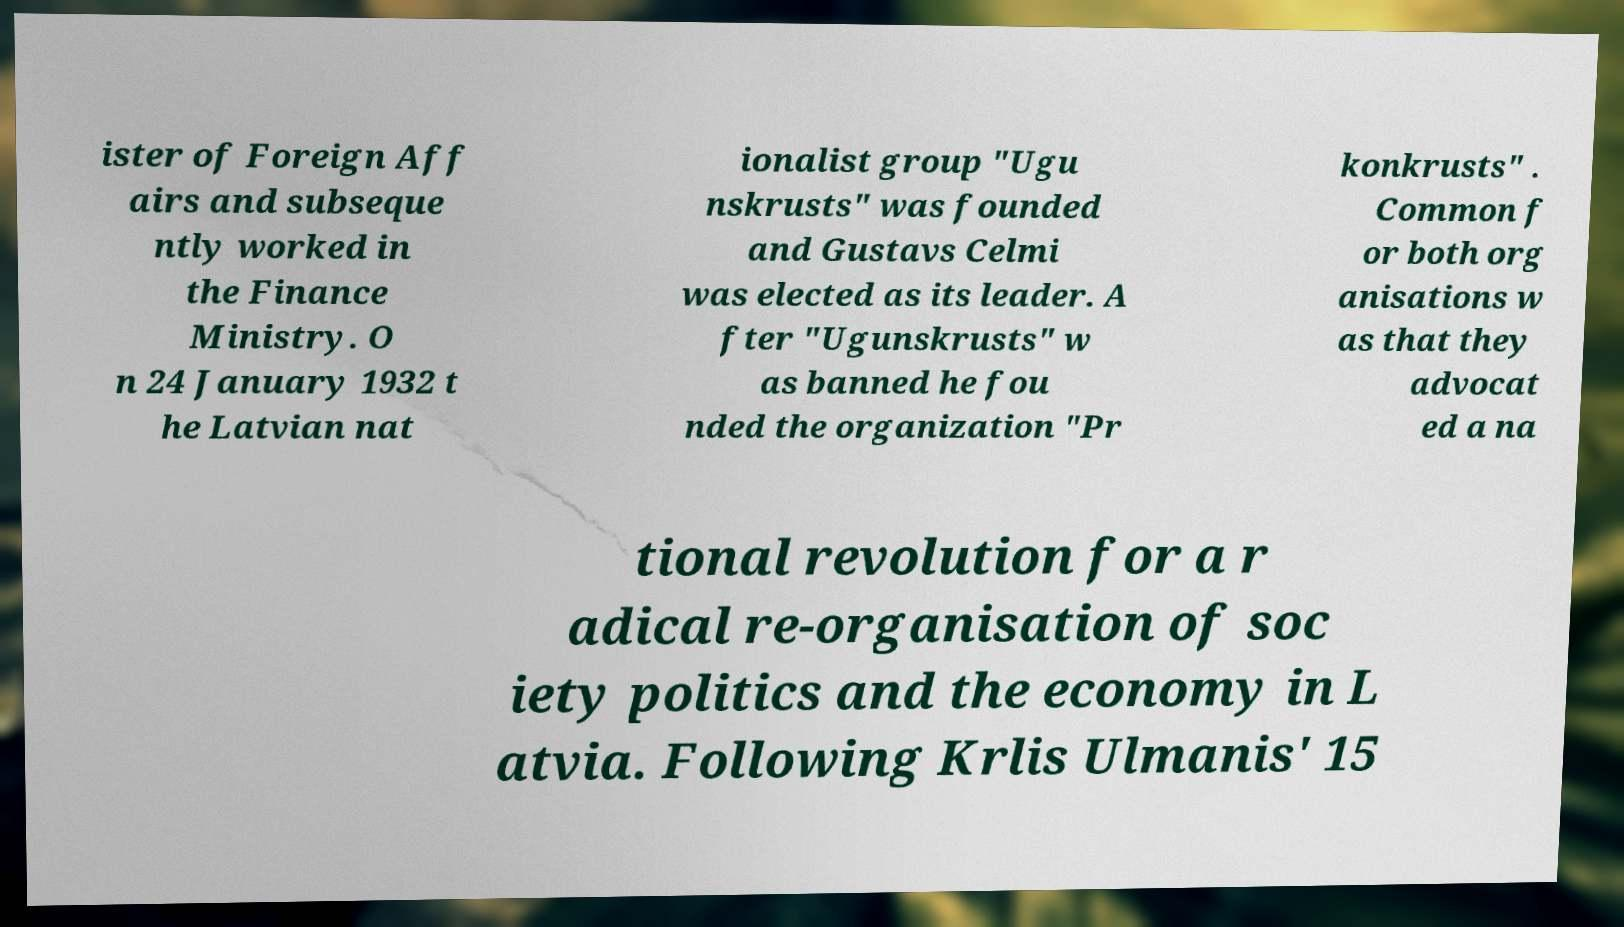For documentation purposes, I need the text within this image transcribed. Could you provide that? ister of Foreign Aff airs and subseque ntly worked in the Finance Ministry. O n 24 January 1932 t he Latvian nat ionalist group "Ugu nskrusts" was founded and Gustavs Celmi was elected as its leader. A fter "Ugunskrusts" w as banned he fou nded the organization "Pr konkrusts" . Common f or both org anisations w as that they advocat ed a na tional revolution for a r adical re-organisation of soc iety politics and the economy in L atvia. Following Krlis Ulmanis' 15 